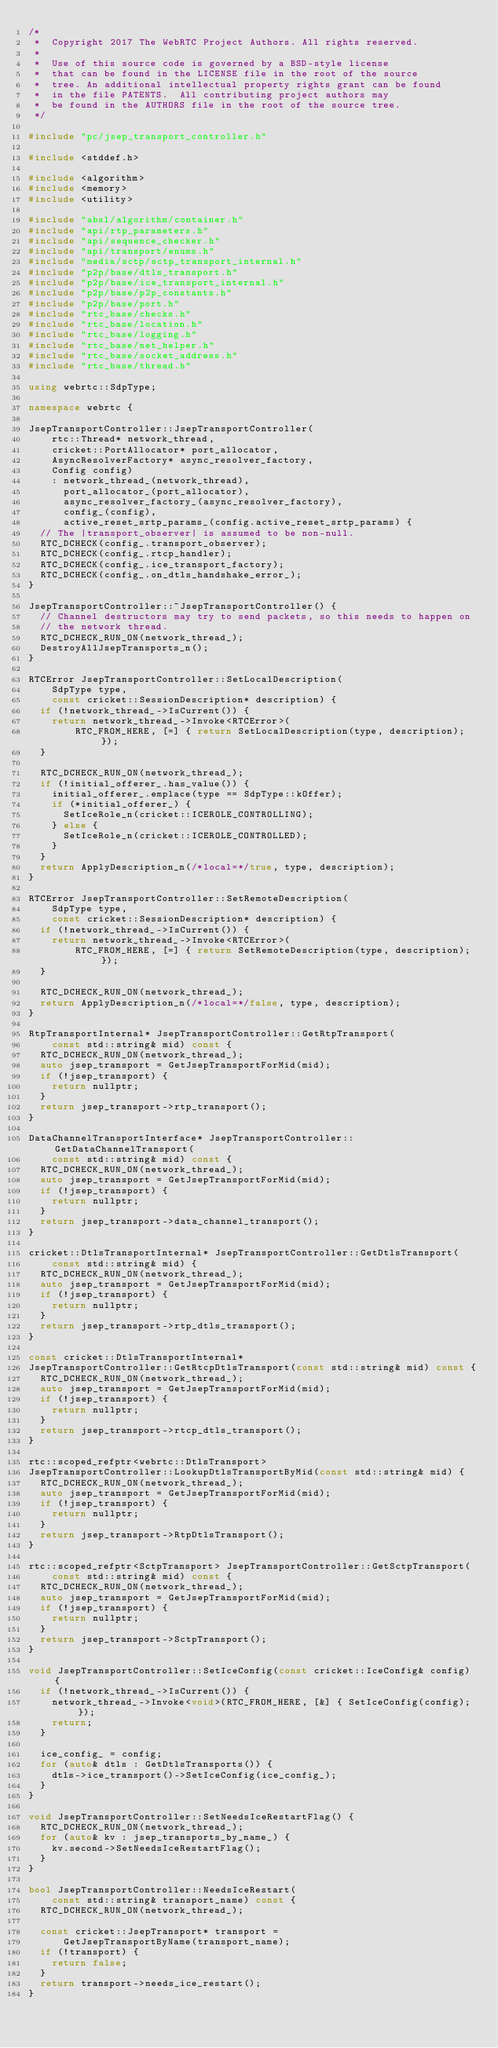Convert code to text. <code><loc_0><loc_0><loc_500><loc_500><_C++_>/*
 *  Copyright 2017 The WebRTC Project Authors. All rights reserved.
 *
 *  Use of this source code is governed by a BSD-style license
 *  that can be found in the LICENSE file in the root of the source
 *  tree. An additional intellectual property rights grant can be found
 *  in the file PATENTS.  All contributing project authors may
 *  be found in the AUTHORS file in the root of the source tree.
 */

#include "pc/jsep_transport_controller.h"

#include <stddef.h>

#include <algorithm>
#include <memory>
#include <utility>

#include "absl/algorithm/container.h"
#include "api/rtp_parameters.h"
#include "api/sequence_checker.h"
#include "api/transport/enums.h"
#include "media/sctp/sctp_transport_internal.h"
#include "p2p/base/dtls_transport.h"
#include "p2p/base/ice_transport_internal.h"
#include "p2p/base/p2p_constants.h"
#include "p2p/base/port.h"
#include "rtc_base/checks.h"
#include "rtc_base/location.h"
#include "rtc_base/logging.h"
#include "rtc_base/net_helper.h"
#include "rtc_base/socket_address.h"
#include "rtc_base/thread.h"

using webrtc::SdpType;

namespace webrtc {

JsepTransportController::JsepTransportController(
    rtc::Thread* network_thread,
    cricket::PortAllocator* port_allocator,
    AsyncResolverFactory* async_resolver_factory,
    Config config)
    : network_thread_(network_thread),
      port_allocator_(port_allocator),
      async_resolver_factory_(async_resolver_factory),
      config_(config),
      active_reset_srtp_params_(config.active_reset_srtp_params) {
  // The |transport_observer| is assumed to be non-null.
  RTC_DCHECK(config_.transport_observer);
  RTC_DCHECK(config_.rtcp_handler);
  RTC_DCHECK(config_.ice_transport_factory);
  RTC_DCHECK(config_.on_dtls_handshake_error_);
}

JsepTransportController::~JsepTransportController() {
  // Channel destructors may try to send packets, so this needs to happen on
  // the network thread.
  RTC_DCHECK_RUN_ON(network_thread_);
  DestroyAllJsepTransports_n();
}

RTCError JsepTransportController::SetLocalDescription(
    SdpType type,
    const cricket::SessionDescription* description) {
  if (!network_thread_->IsCurrent()) {
    return network_thread_->Invoke<RTCError>(
        RTC_FROM_HERE, [=] { return SetLocalDescription(type, description); });
  }

  RTC_DCHECK_RUN_ON(network_thread_);
  if (!initial_offerer_.has_value()) {
    initial_offerer_.emplace(type == SdpType::kOffer);
    if (*initial_offerer_) {
      SetIceRole_n(cricket::ICEROLE_CONTROLLING);
    } else {
      SetIceRole_n(cricket::ICEROLE_CONTROLLED);
    }
  }
  return ApplyDescription_n(/*local=*/true, type, description);
}

RTCError JsepTransportController::SetRemoteDescription(
    SdpType type,
    const cricket::SessionDescription* description) {
  if (!network_thread_->IsCurrent()) {
    return network_thread_->Invoke<RTCError>(
        RTC_FROM_HERE, [=] { return SetRemoteDescription(type, description); });
  }

  RTC_DCHECK_RUN_ON(network_thread_);
  return ApplyDescription_n(/*local=*/false, type, description);
}

RtpTransportInternal* JsepTransportController::GetRtpTransport(
    const std::string& mid) const {
  RTC_DCHECK_RUN_ON(network_thread_);
  auto jsep_transport = GetJsepTransportForMid(mid);
  if (!jsep_transport) {
    return nullptr;
  }
  return jsep_transport->rtp_transport();
}

DataChannelTransportInterface* JsepTransportController::GetDataChannelTransport(
    const std::string& mid) const {
  RTC_DCHECK_RUN_ON(network_thread_);
  auto jsep_transport = GetJsepTransportForMid(mid);
  if (!jsep_transport) {
    return nullptr;
  }
  return jsep_transport->data_channel_transport();
}

cricket::DtlsTransportInternal* JsepTransportController::GetDtlsTransport(
    const std::string& mid) {
  RTC_DCHECK_RUN_ON(network_thread_);
  auto jsep_transport = GetJsepTransportForMid(mid);
  if (!jsep_transport) {
    return nullptr;
  }
  return jsep_transport->rtp_dtls_transport();
}

const cricket::DtlsTransportInternal*
JsepTransportController::GetRtcpDtlsTransport(const std::string& mid) const {
  RTC_DCHECK_RUN_ON(network_thread_);
  auto jsep_transport = GetJsepTransportForMid(mid);
  if (!jsep_transport) {
    return nullptr;
  }
  return jsep_transport->rtcp_dtls_transport();
}

rtc::scoped_refptr<webrtc::DtlsTransport>
JsepTransportController::LookupDtlsTransportByMid(const std::string& mid) {
  RTC_DCHECK_RUN_ON(network_thread_);
  auto jsep_transport = GetJsepTransportForMid(mid);
  if (!jsep_transport) {
    return nullptr;
  }
  return jsep_transport->RtpDtlsTransport();
}

rtc::scoped_refptr<SctpTransport> JsepTransportController::GetSctpTransport(
    const std::string& mid) const {
  RTC_DCHECK_RUN_ON(network_thread_);
  auto jsep_transport = GetJsepTransportForMid(mid);
  if (!jsep_transport) {
    return nullptr;
  }
  return jsep_transport->SctpTransport();
}

void JsepTransportController::SetIceConfig(const cricket::IceConfig& config) {
  if (!network_thread_->IsCurrent()) {
    network_thread_->Invoke<void>(RTC_FROM_HERE, [&] { SetIceConfig(config); });
    return;
  }

  ice_config_ = config;
  for (auto& dtls : GetDtlsTransports()) {
    dtls->ice_transport()->SetIceConfig(ice_config_);
  }
}

void JsepTransportController::SetNeedsIceRestartFlag() {
  RTC_DCHECK_RUN_ON(network_thread_);
  for (auto& kv : jsep_transports_by_name_) {
    kv.second->SetNeedsIceRestartFlag();
  }
}

bool JsepTransportController::NeedsIceRestart(
    const std::string& transport_name) const {
  RTC_DCHECK_RUN_ON(network_thread_);

  const cricket::JsepTransport* transport =
      GetJsepTransportByName(transport_name);
  if (!transport) {
    return false;
  }
  return transport->needs_ice_restart();
}
</code> 